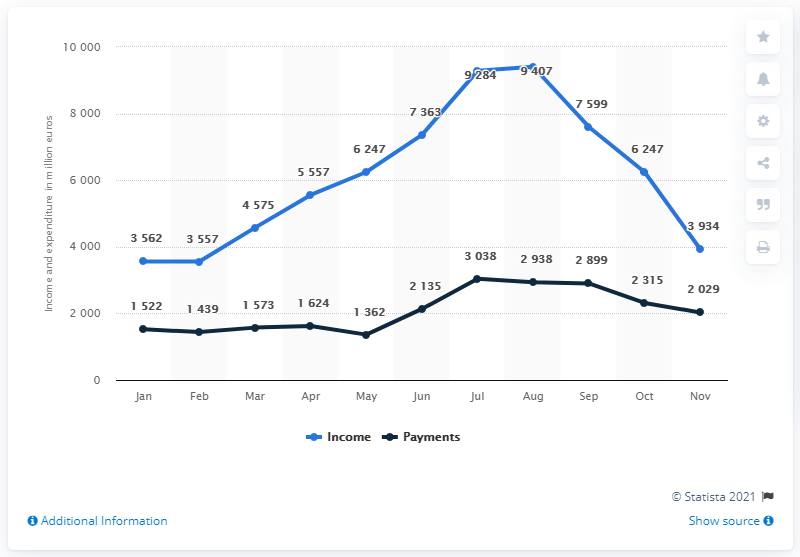Outline some significant characteristics in this image. In August 2019, the estimated monthly income from international tourism was 9,407 million U.S. dollars. 